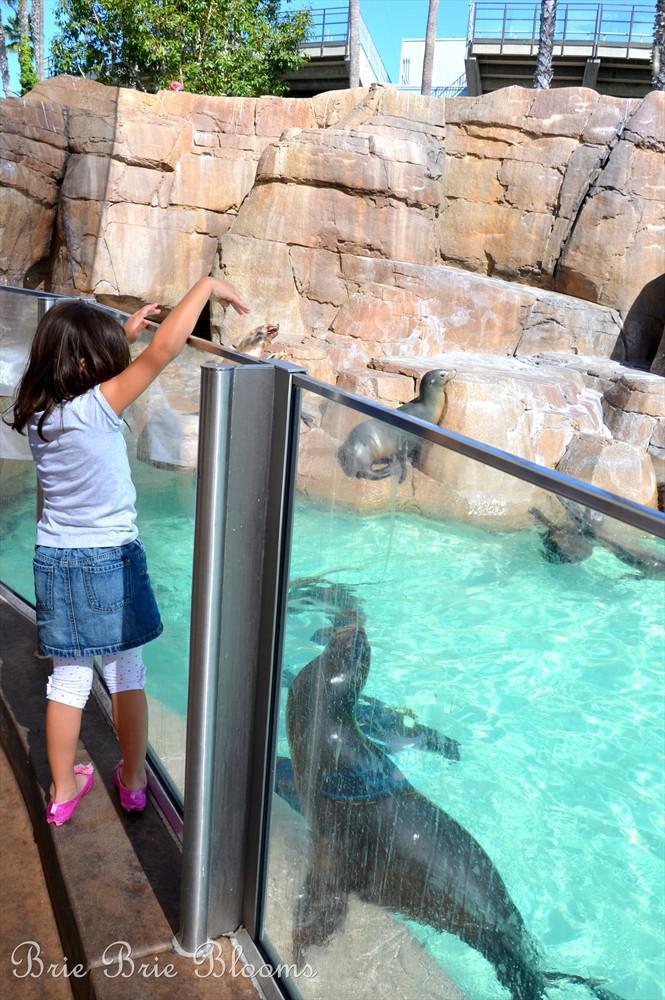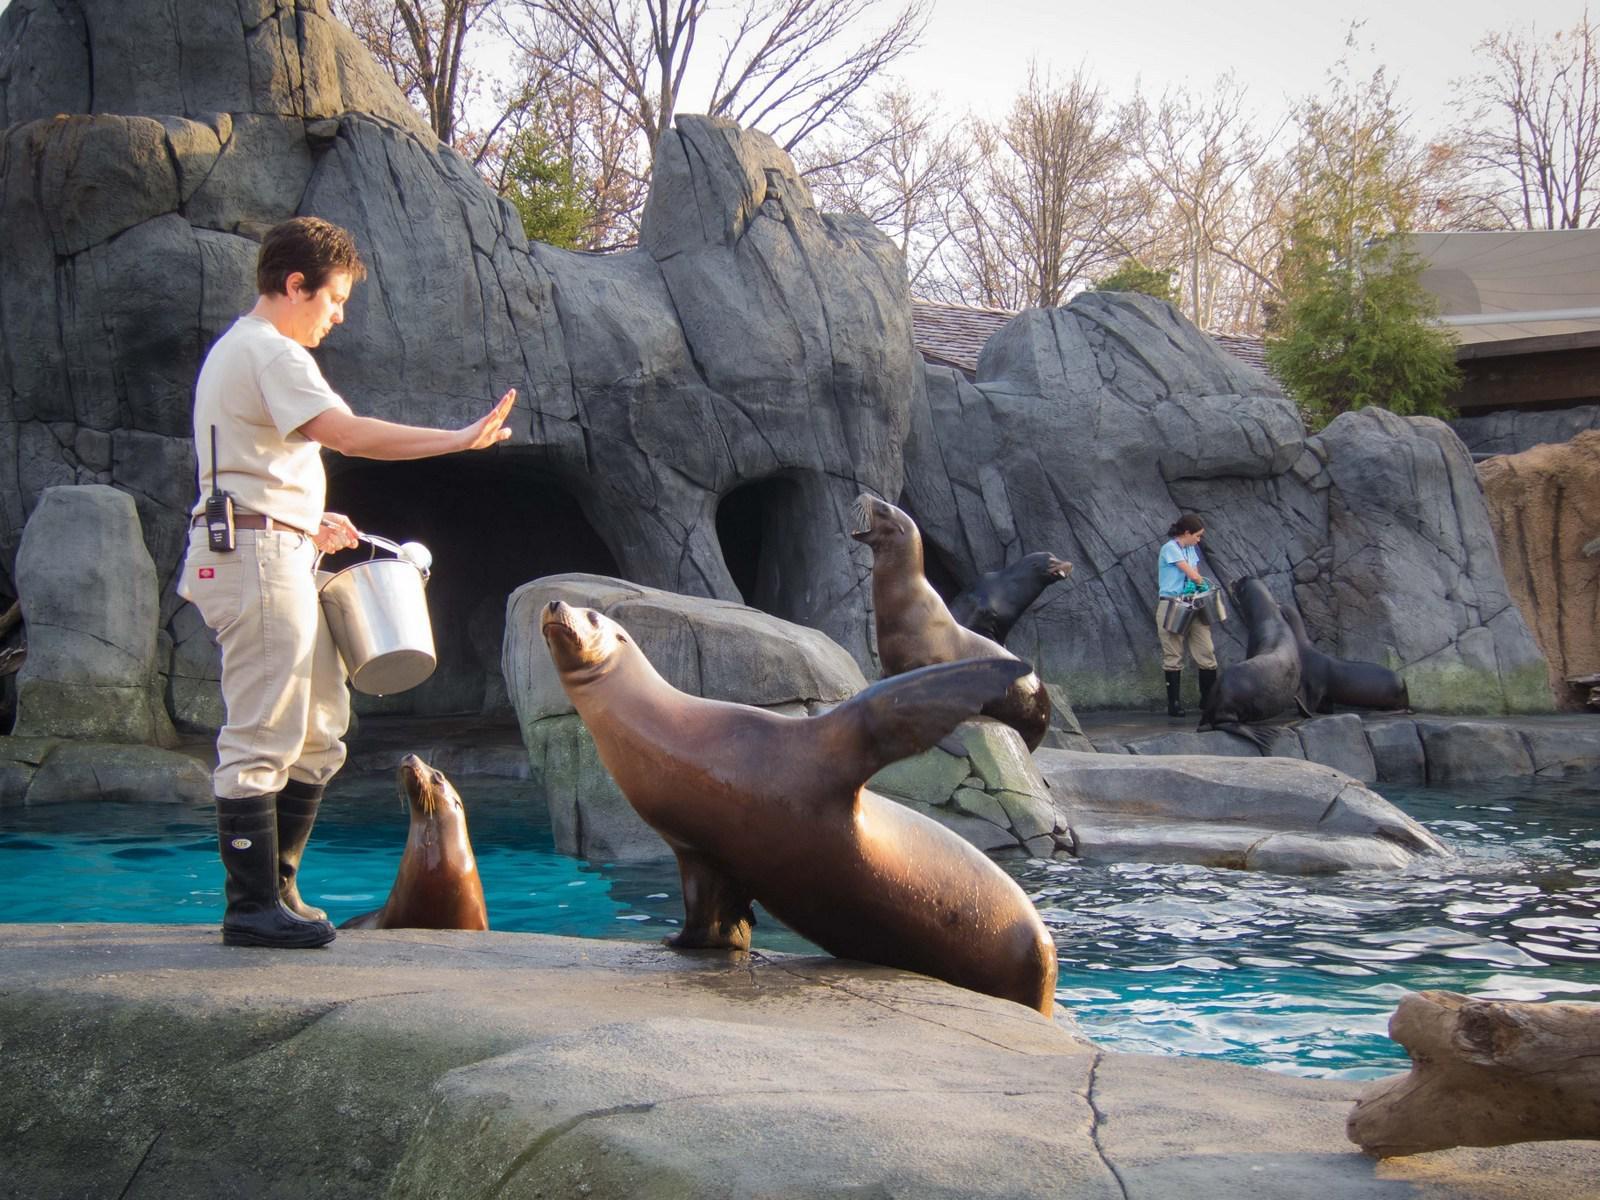The first image is the image on the left, the second image is the image on the right. Considering the images on both sides, is "there are seals in a pool encased in glass fencing" valid? Answer yes or no. Yes. The first image is the image on the left, the second image is the image on the right. For the images shown, is this caption "Each image shows a seal performing in a show, and one image shows a seal balancing on a stone ledge with at least part of its body held in the air." true? Answer yes or no. Yes. 